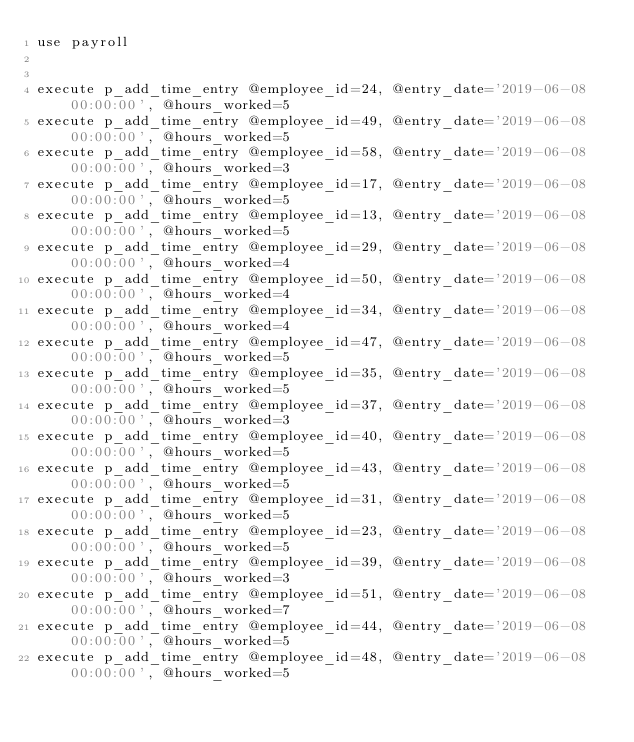Convert code to text. <code><loc_0><loc_0><loc_500><loc_500><_SQL_>use payroll


execute p_add_time_entry @employee_id=24, @entry_date='2019-06-08 00:00:00', @hours_worked=5
execute p_add_time_entry @employee_id=49, @entry_date='2019-06-08 00:00:00', @hours_worked=5
execute p_add_time_entry @employee_id=58, @entry_date='2019-06-08 00:00:00', @hours_worked=3
execute p_add_time_entry @employee_id=17, @entry_date='2019-06-08 00:00:00', @hours_worked=5
execute p_add_time_entry @employee_id=13, @entry_date='2019-06-08 00:00:00', @hours_worked=5
execute p_add_time_entry @employee_id=29, @entry_date='2019-06-08 00:00:00', @hours_worked=4
execute p_add_time_entry @employee_id=50, @entry_date='2019-06-08 00:00:00', @hours_worked=4
execute p_add_time_entry @employee_id=34, @entry_date='2019-06-08 00:00:00', @hours_worked=4
execute p_add_time_entry @employee_id=47, @entry_date='2019-06-08 00:00:00', @hours_worked=5
execute p_add_time_entry @employee_id=35, @entry_date='2019-06-08 00:00:00', @hours_worked=5
execute p_add_time_entry @employee_id=37, @entry_date='2019-06-08 00:00:00', @hours_worked=3
execute p_add_time_entry @employee_id=40, @entry_date='2019-06-08 00:00:00', @hours_worked=5
execute p_add_time_entry @employee_id=43, @entry_date='2019-06-08 00:00:00', @hours_worked=5
execute p_add_time_entry @employee_id=31, @entry_date='2019-06-08 00:00:00', @hours_worked=5
execute p_add_time_entry @employee_id=23, @entry_date='2019-06-08 00:00:00', @hours_worked=5
execute p_add_time_entry @employee_id=39, @entry_date='2019-06-08 00:00:00', @hours_worked=3
execute p_add_time_entry @employee_id=51, @entry_date='2019-06-08 00:00:00', @hours_worked=7
execute p_add_time_entry @employee_id=44, @entry_date='2019-06-08 00:00:00', @hours_worked=5
execute p_add_time_entry @employee_id=48, @entry_date='2019-06-08 00:00:00', @hours_worked=5</code> 